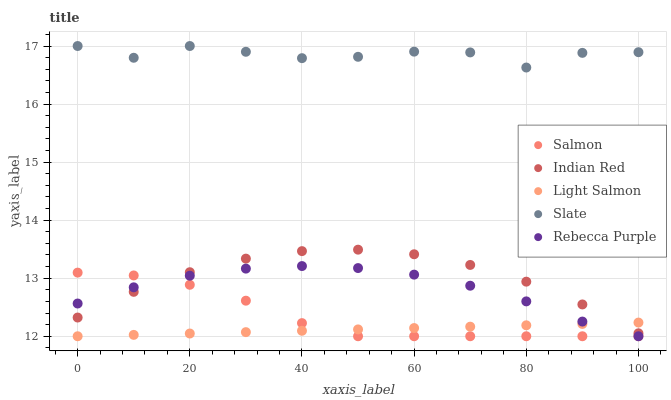Does Light Salmon have the minimum area under the curve?
Answer yes or no. Yes. Does Slate have the maximum area under the curve?
Answer yes or no. Yes. Does Salmon have the minimum area under the curve?
Answer yes or no. No. Does Salmon have the maximum area under the curve?
Answer yes or no. No. Is Light Salmon the smoothest?
Answer yes or no. Yes. Is Slate the roughest?
Answer yes or no. Yes. Is Salmon the smoothest?
Answer yes or no. No. Is Salmon the roughest?
Answer yes or no. No. Does Light Salmon have the lowest value?
Answer yes or no. Yes. Does Slate have the lowest value?
Answer yes or no. No. Does Slate have the highest value?
Answer yes or no. Yes. Does Salmon have the highest value?
Answer yes or no. No. Is Rebecca Purple less than Slate?
Answer yes or no. Yes. Is Slate greater than Indian Red?
Answer yes or no. Yes. Does Rebecca Purple intersect Salmon?
Answer yes or no. Yes. Is Rebecca Purple less than Salmon?
Answer yes or no. No. Is Rebecca Purple greater than Salmon?
Answer yes or no. No. Does Rebecca Purple intersect Slate?
Answer yes or no. No. 